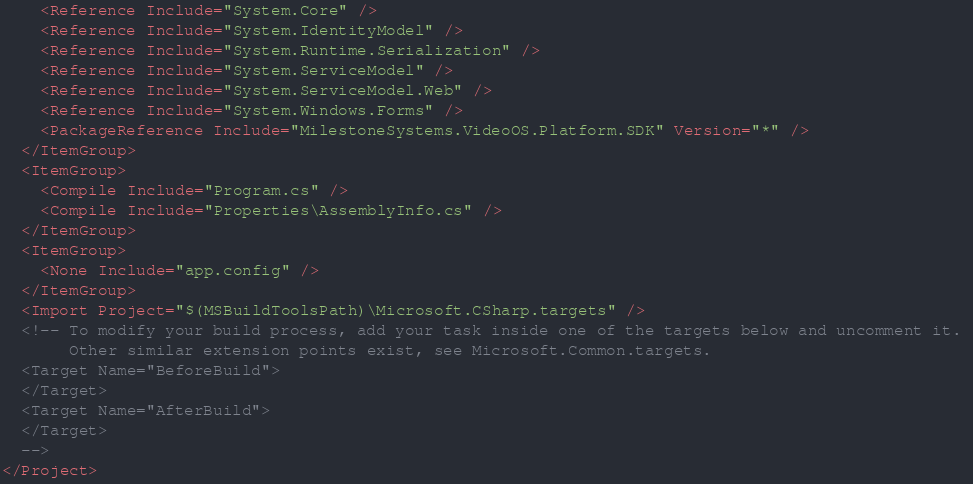Convert code to text. <code><loc_0><loc_0><loc_500><loc_500><_XML_>    <Reference Include="System.Core" />
    <Reference Include="System.IdentityModel" />
    <Reference Include="System.Runtime.Serialization" />
    <Reference Include="System.ServiceModel" />
    <Reference Include="System.ServiceModel.Web" />
    <Reference Include="System.Windows.Forms" />
    <PackageReference Include="MilestoneSystems.VideoOS.Platform.SDK" Version="*" />
  </ItemGroup>
  <ItemGroup>
    <Compile Include="Program.cs" />
    <Compile Include="Properties\AssemblyInfo.cs" />
  </ItemGroup>
  <ItemGroup>
    <None Include="app.config" />
  </ItemGroup>
  <Import Project="$(MSBuildToolsPath)\Microsoft.CSharp.targets" />
  <!-- To modify your build process, add your task inside one of the targets below and uncomment it. 
       Other similar extension points exist, see Microsoft.Common.targets.
  <Target Name="BeforeBuild">
  </Target>
  <Target Name="AfterBuild">
  </Target>
  -->
</Project>
</code> 